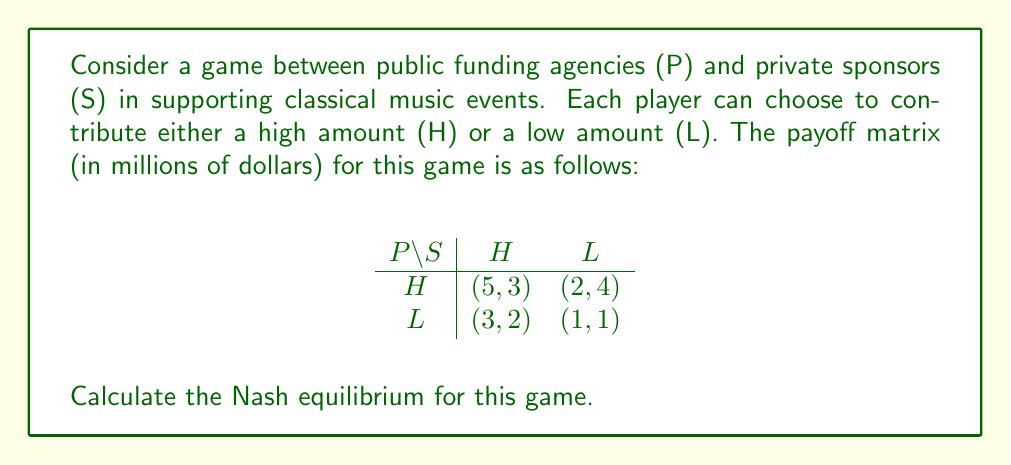Can you answer this question? To find the Nash equilibrium, we need to determine the best response for each player given the other player's strategy.

1. For Public funding agencies (P):
   - If S chooses H: P's best response is H (5 > 3)
   - If S chooses L: P's best response is H (2 > 1)

2. For Private sponsors (S):
   - If P chooses H: S's best response is L (4 > 3)
   - If P chooses L: S's best response is H (2 > 1)

We can mark the best responses in the payoff matrix:

$$
\begin{array}{c|cc}
P \backslash S & H & L \\
\hline
H & (5^*, 3) & (2^*, 4^*) \\
L & (3, 2^*) & (1, 1)
\end{array}
$$

The Nash equilibrium occurs where both players are playing their best responses simultaneously. In this case, it's when P chooses H and S chooses L, resulting in payoffs of (2, 4).

This equilibrium reflects a scenario where public funding agencies contribute a high amount while private sponsors contribute a low amount, which aligns with the persona's belief that classical music should rely more on public funding.
Answer: The Nash equilibrium for this game is (H, L), where public funding agencies contribute a high amount and private sponsors contribute a low amount, resulting in payoffs of (2, 4) million dollars for P and S respectively. 